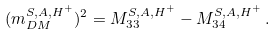Convert formula to latex. <formula><loc_0><loc_0><loc_500><loc_500>( m ^ { S , A , H ^ { + } } _ { D M } ) ^ { 2 } = M ^ { S , A , H ^ { + } } _ { 3 3 } - M ^ { S , A , H ^ { + } } _ { 3 4 } \, .</formula> 